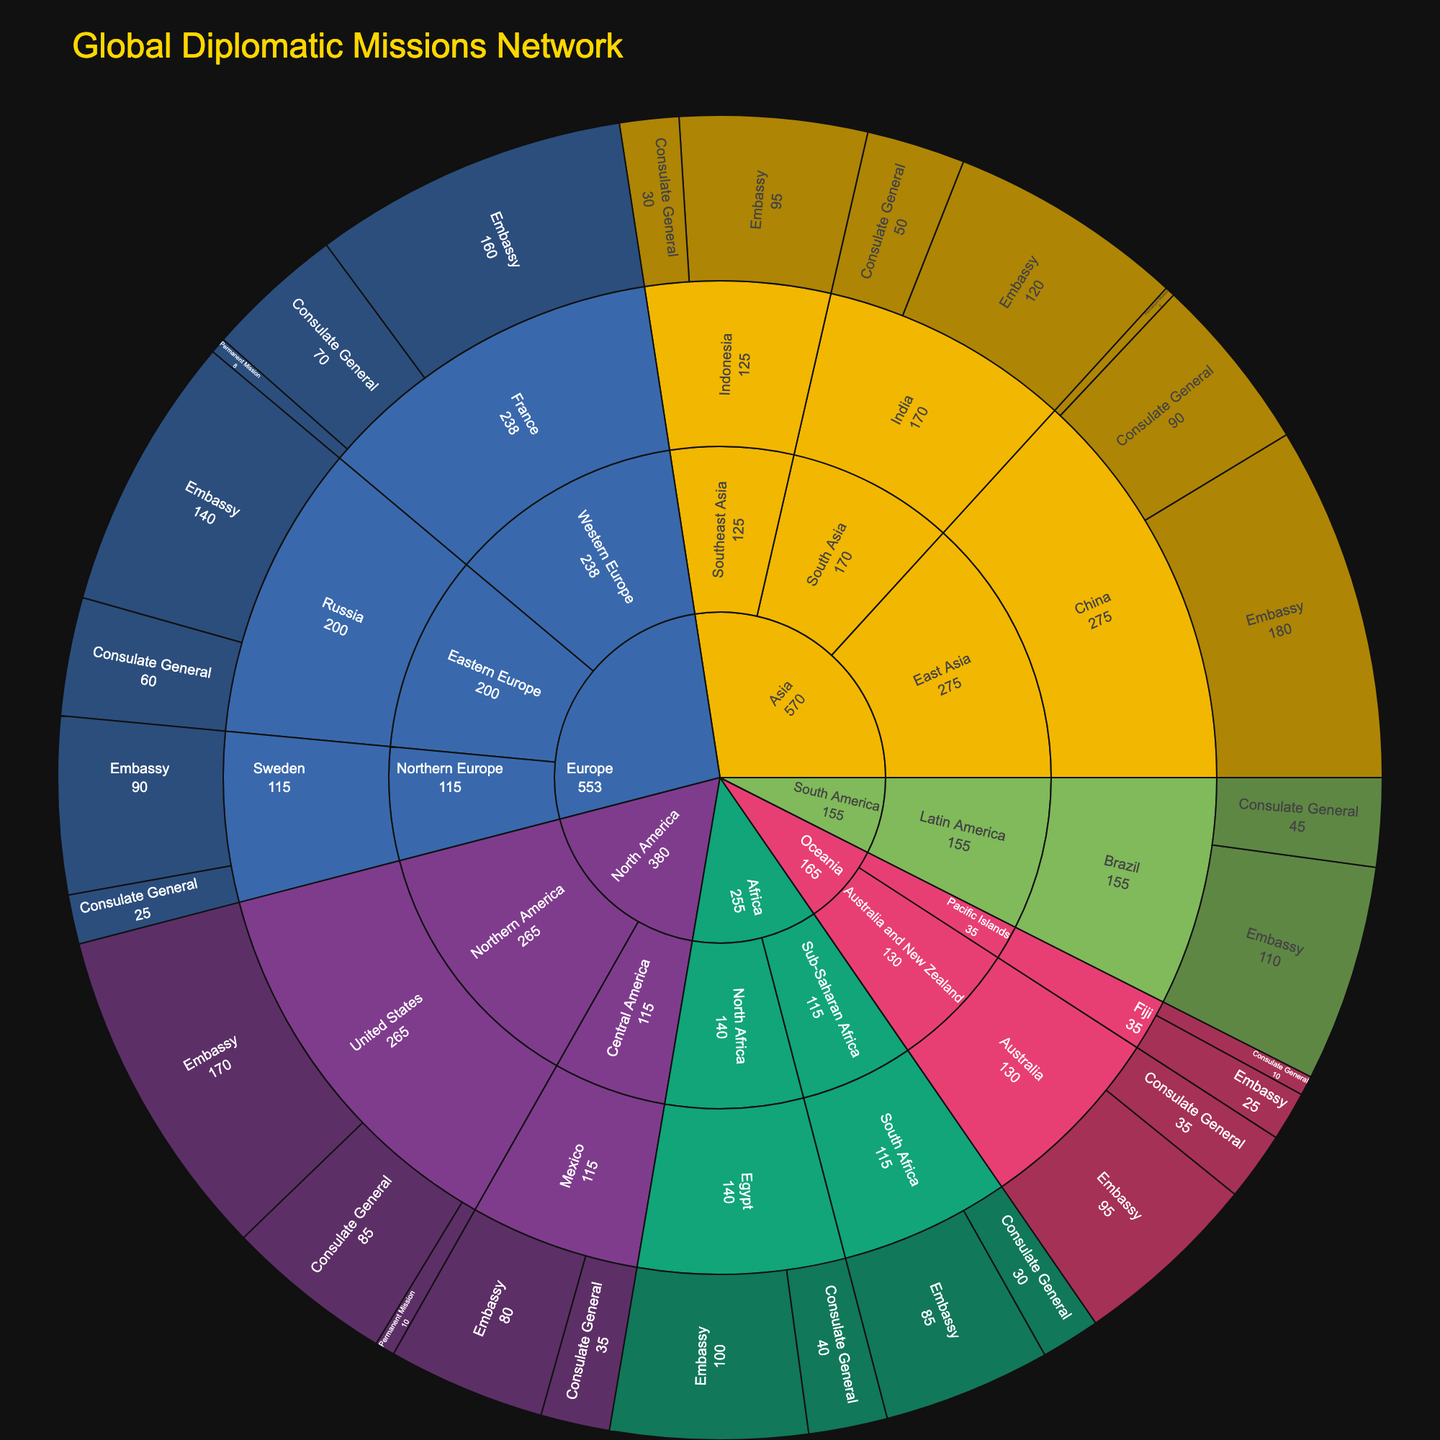What is the title of the figure? The title is displayed at the top of the figure in a larger font size and a distinct color (gold). It provides a summary of the plot's content.
Answer: Global Diplomatic Missions Network Which continent has the most diplomatic missions overall? The figure is grouped by continents, and the largest segment corresponds to the continent with the most total missions.
Answer: Asia How many Consulate Generals does China have? The segment for Consulate General within China's subtree indicates the number of Consulate Generals.
Answer: 90 What type of diplomatic mission is the largest in North America? By examining the segments within North America's subtree, the largest segment represents the type with the highest count.
Answer: Embassy How does the number of embassies in Russia compare to those in France? Navigate to the respective country's subsections and compare the mission counts shown for embassies.
Answer: France has more embassies (160) compared to Russia (140) Which region within Europe has the most diplomatic missions? Look at the subtrees within Europe and sum up the counts for each region to determine which has the highest total.
Answer: Western Europe What is the total number of missions in Oceania? Sum the counts of all mission types in Oceania by adding up the numbers from Australia's and Fiji's subtrees.
Answer: 165 How do the Permanent Missions in the United States compare to those in China? Locate the Permanent Mission segments for each country and compare their counts.
Answer: China has fewer Permanent Missions (5) compared to the United States (10) What is the smallest embassy count in any country listed? Identify the smallest embassy count among all segments labeled as Embassy. This is found by comparing the counts visually.
Answer: Fiji with 25 How many missions does Brazil have in total, including all types? Add the counts for all types of missions listed under Brazil's subtree.
Answer: 155 